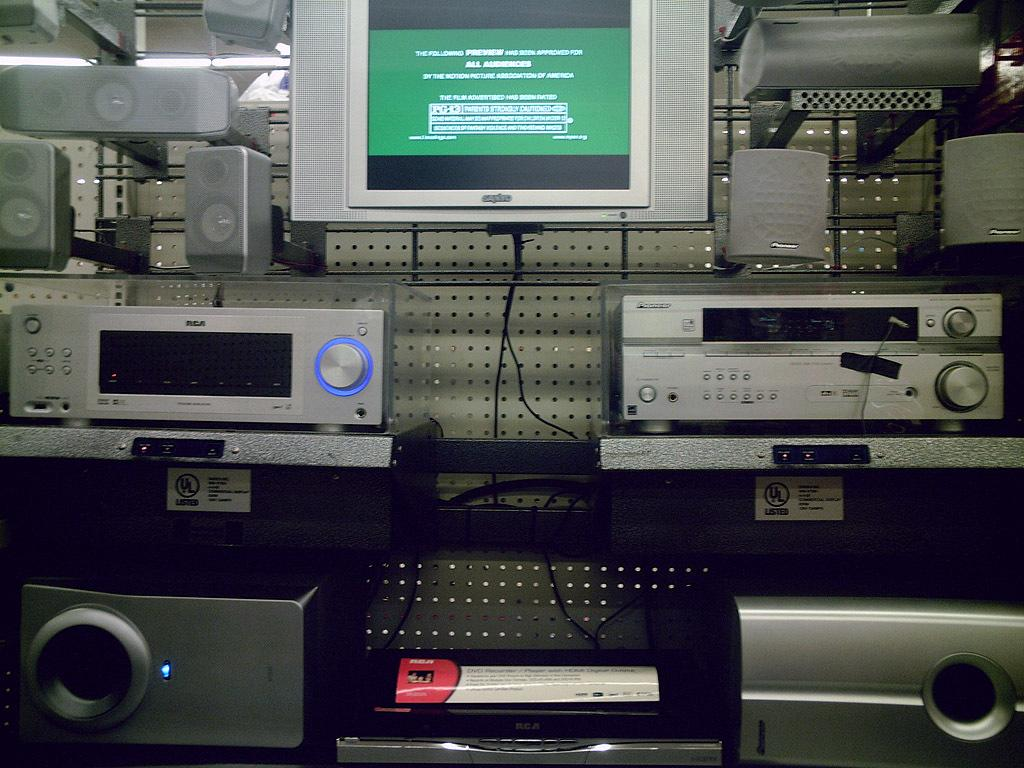<image>
Render a clear and concise summary of the photo. A TV turned on above of electronic devices that is showing a preview. 